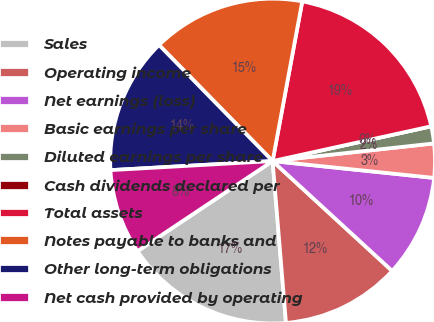<chart> <loc_0><loc_0><loc_500><loc_500><pie_chart><fcel>Sales<fcel>Operating income<fcel>Net earnings (loss)<fcel>Basic earnings per share<fcel>Diluted earnings per share<fcel>Cash dividends declared per<fcel>Total assets<fcel>Notes payable to banks and<fcel>Other long-term obligations<fcel>Net cash provided by operating<nl><fcel>16.95%<fcel>11.86%<fcel>10.17%<fcel>3.39%<fcel>1.7%<fcel>0.0%<fcel>18.64%<fcel>15.25%<fcel>13.56%<fcel>8.47%<nl></chart> 